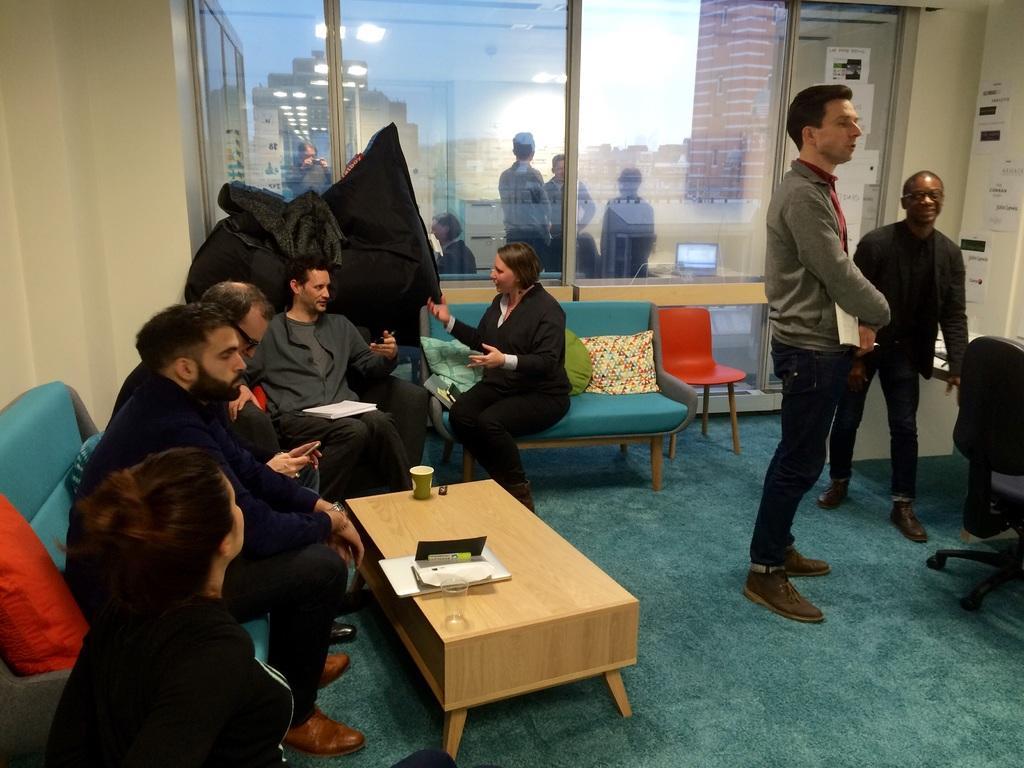Could you give a brief overview of what you see in this image? There are five persons sitting in a blue sofa and there is a table in front of them which contains two glasses and some papers on it and there are two persons standing in the right corner and there is also a window behind them. 